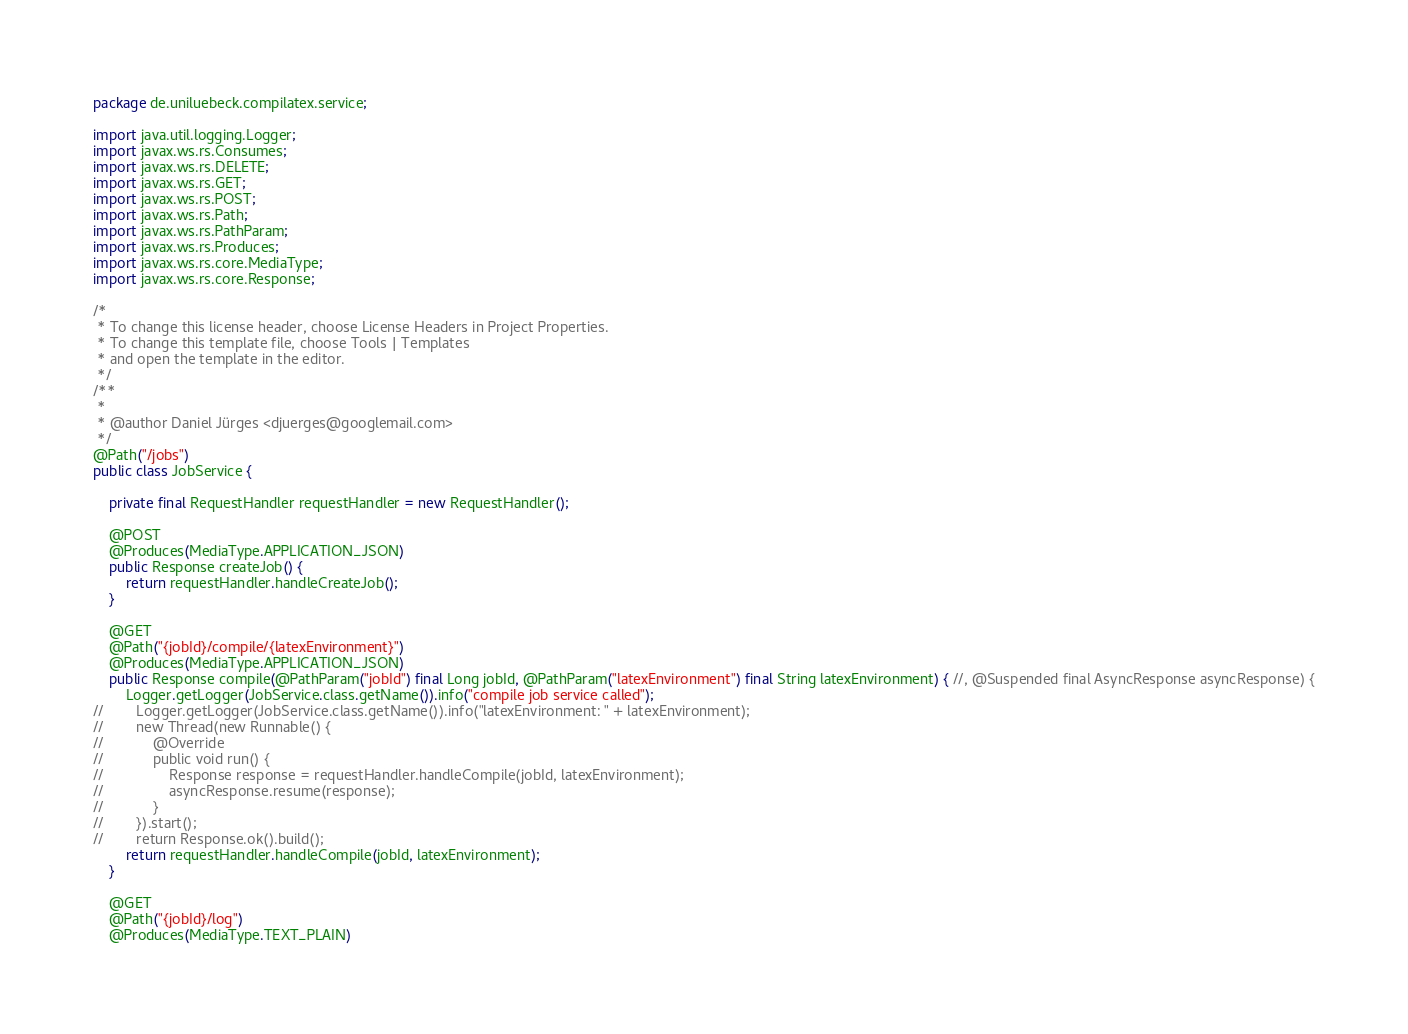Convert code to text. <code><loc_0><loc_0><loc_500><loc_500><_Java_>package de.uniluebeck.compilatex.service;

import java.util.logging.Logger;
import javax.ws.rs.Consumes;
import javax.ws.rs.DELETE;
import javax.ws.rs.GET;
import javax.ws.rs.POST;
import javax.ws.rs.Path;
import javax.ws.rs.PathParam;
import javax.ws.rs.Produces;
import javax.ws.rs.core.MediaType;
import javax.ws.rs.core.Response;

/*
 * To change this license header, choose License Headers in Project Properties.
 * To change this template file, choose Tools | Templates
 * and open the template in the editor.
 */
/**
 *
 * @author Daniel Jürges <djuerges@googlemail.com>
 */
@Path("/jobs")
public class JobService {

    private final RequestHandler requestHandler = new RequestHandler();

    @POST
    @Produces(MediaType.APPLICATION_JSON)
    public Response createJob() {
        return requestHandler.handleCreateJob();
    }

    @GET
    @Path("{jobId}/compile/{latexEnvironment}")
    @Produces(MediaType.APPLICATION_JSON)
    public Response compile(@PathParam("jobId") final Long jobId, @PathParam("latexEnvironment") final String latexEnvironment) { //, @Suspended final AsyncResponse asyncResponse) {
        Logger.getLogger(JobService.class.getName()).info("compile job service called");
//        Logger.getLogger(JobService.class.getName()).info("latexEnvironment: " + latexEnvironment);
//        new Thread(new Runnable() {
//            @Override
//            public void run() {
//                Response response = requestHandler.handleCompile(jobId, latexEnvironment);
//                asyncResponse.resume(response);
//            }
//        }).start();
//        return Response.ok().build();
        return requestHandler.handleCompile(jobId, latexEnvironment);
    }

    @GET
    @Path("{jobId}/log")
    @Produces(MediaType.TEXT_PLAIN)</code> 